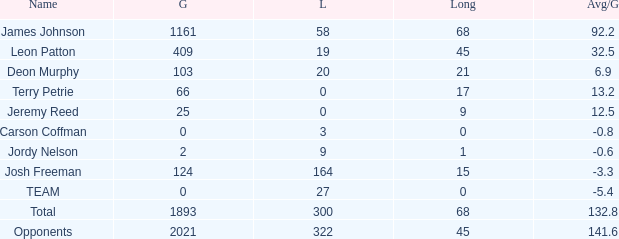How many losses did leon patton have with the longest gain higher than 45? 0.0. 